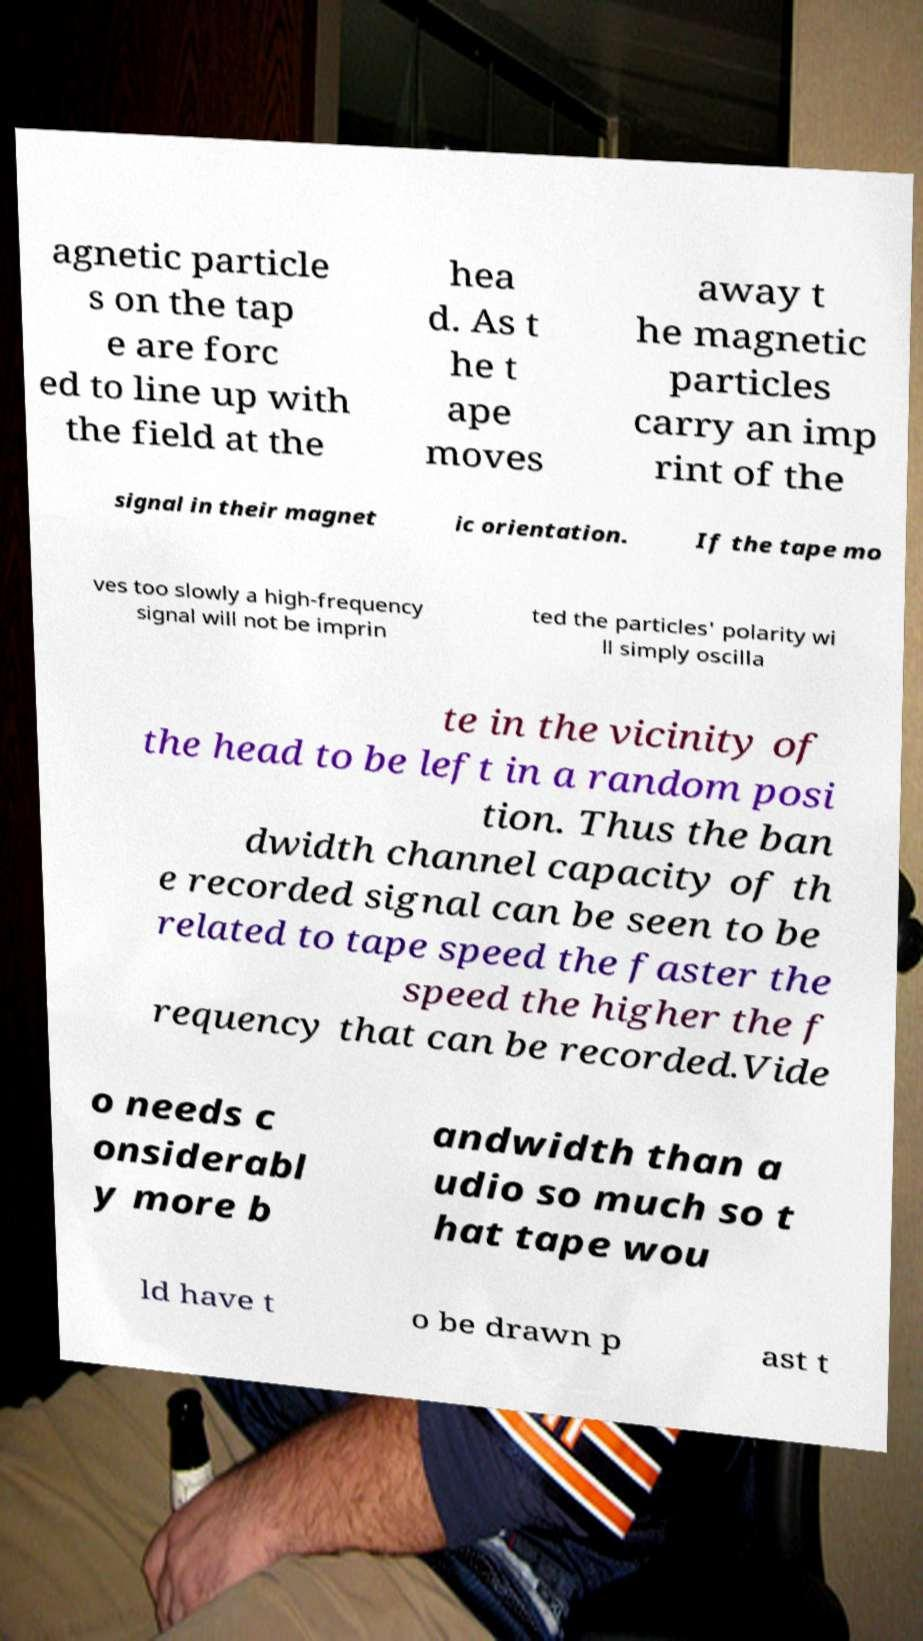Can you accurately transcribe the text from the provided image for me? agnetic particle s on the tap e are forc ed to line up with the field at the hea d. As t he t ape moves away t he magnetic particles carry an imp rint of the signal in their magnet ic orientation. If the tape mo ves too slowly a high-frequency signal will not be imprin ted the particles' polarity wi ll simply oscilla te in the vicinity of the head to be left in a random posi tion. Thus the ban dwidth channel capacity of th e recorded signal can be seen to be related to tape speed the faster the speed the higher the f requency that can be recorded.Vide o needs c onsiderabl y more b andwidth than a udio so much so t hat tape wou ld have t o be drawn p ast t 